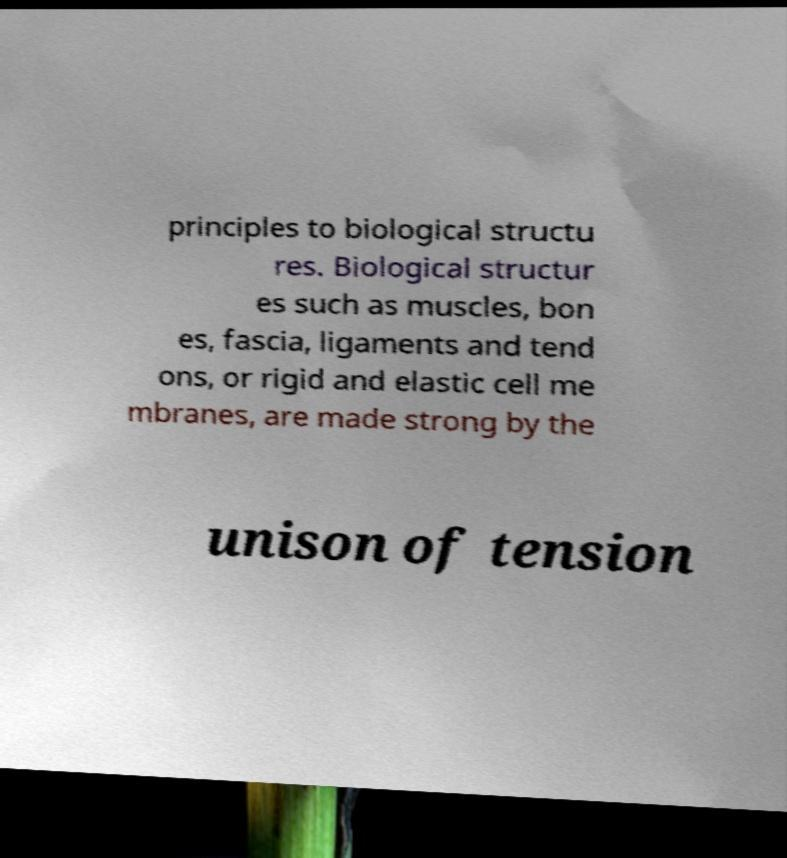There's text embedded in this image that I need extracted. Can you transcribe it verbatim? principles to biological structu res. Biological structur es such as muscles, bon es, fascia, ligaments and tend ons, or rigid and elastic cell me mbranes, are made strong by the unison of tension 